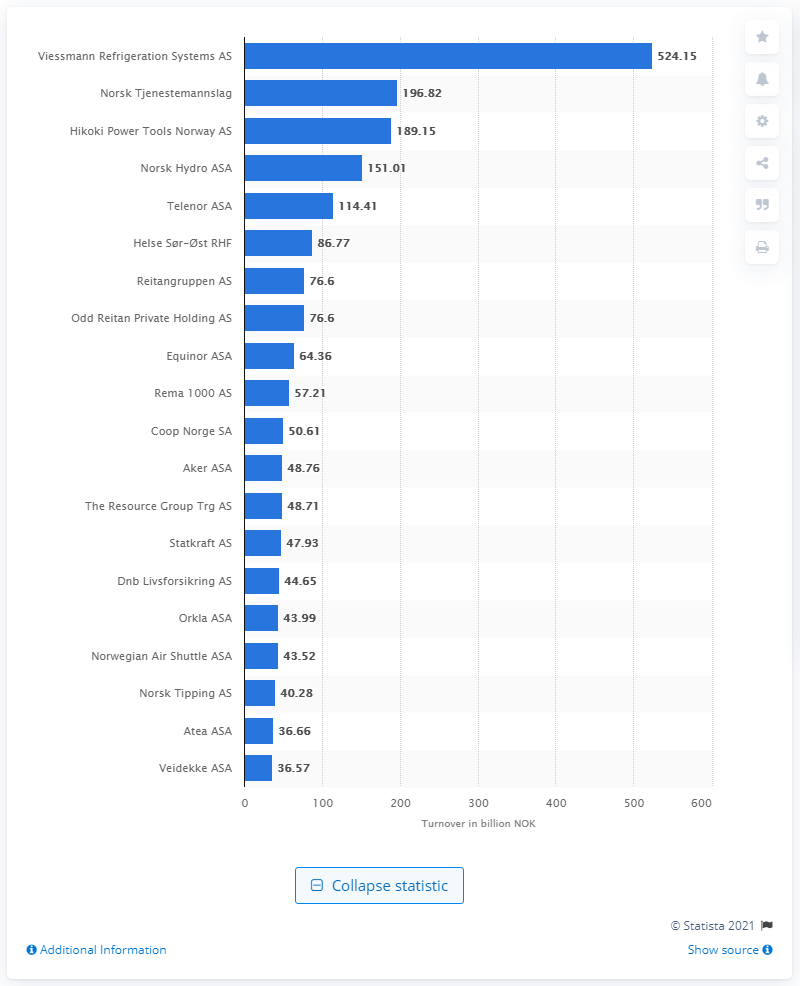Give some essential details in this illustration. As of March 2021, Viessmann Refrigeration Systems AS was the leading Norwegian enterprise. Hikoki Power Tools Norway AS's revenue was 189.15.. Norsk Tjenestemannslag earned a total of 196.82... Norsk Tjenestemannslag was the union that was ranked second in Norway. 